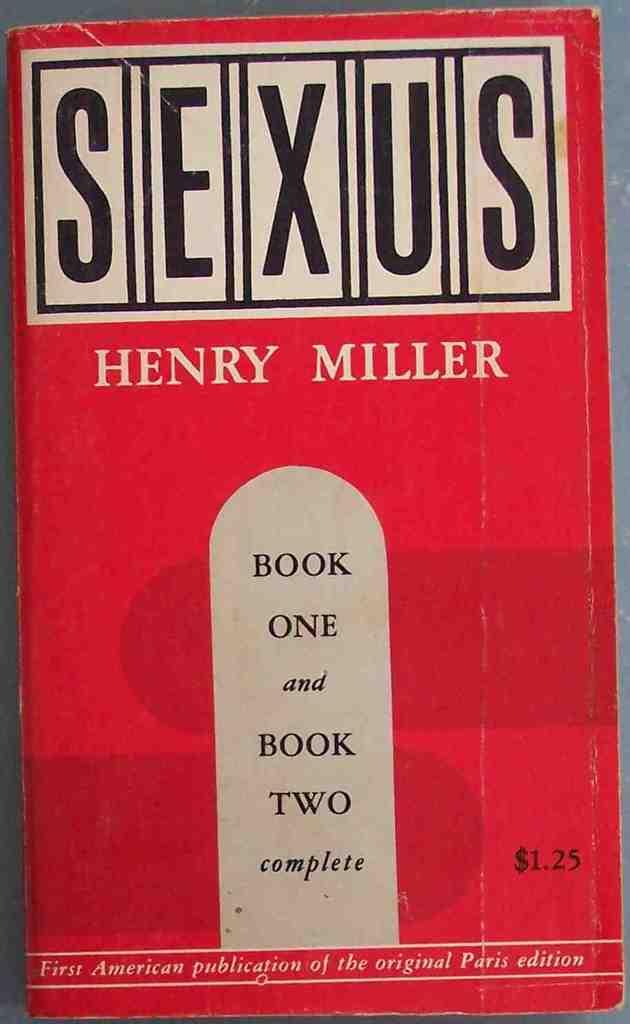Which publication is this?
Ensure brevity in your answer.  Sexus. How much does this cost?
Keep it short and to the point. 1.25. 